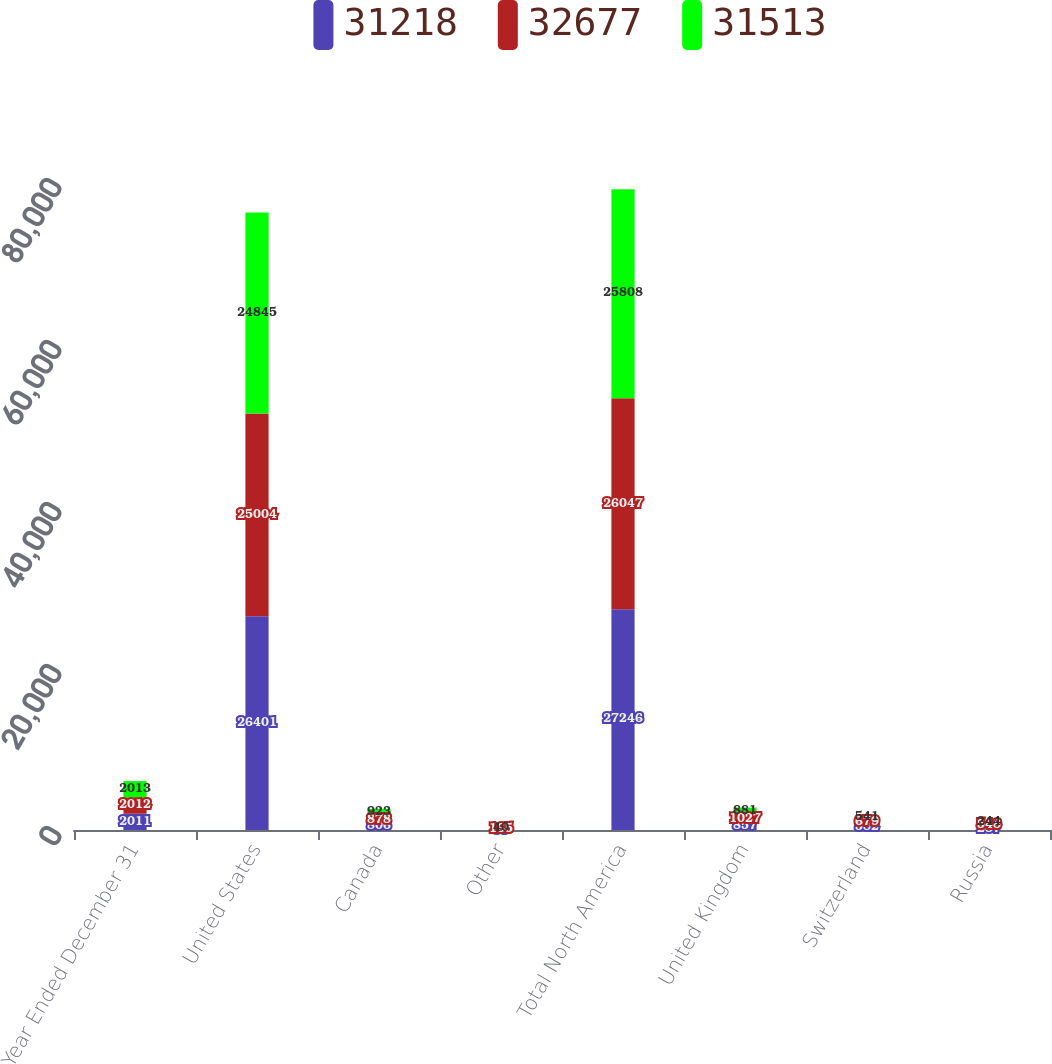Convert chart to OTSL. <chart><loc_0><loc_0><loc_500><loc_500><stacked_bar_chart><ecel><fcel>Year Ended December 31<fcel>United States<fcel>Canada<fcel>Other<fcel>Total North America<fcel>United Kingdom<fcel>Switzerland<fcel>Russia<nl><fcel>31218<fcel>2011<fcel>26401<fcel>806<fcel>39<fcel>27246<fcel>857<fcel>582<fcel>287<nl><fcel>32677<fcel>2012<fcel>25004<fcel>878<fcel>165<fcel>26047<fcel>1027<fcel>679<fcel>548<nl><fcel>31513<fcel>2013<fcel>24845<fcel>923<fcel>40<fcel>25808<fcel>881<fcel>541<fcel>244<nl></chart> 